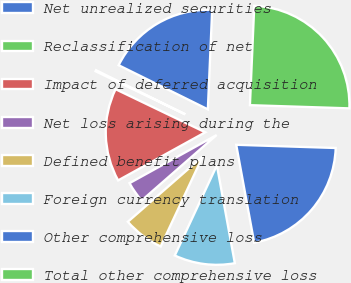Convert chart. <chart><loc_0><loc_0><loc_500><loc_500><pie_chart><fcel>Net unrealized securities<fcel>Reclassification of net<fcel>Impact of deferred acquisition<fcel>Net loss arising during the<fcel>Defined benefit plans<fcel>Foreign currency translation<fcel>Other comprehensive loss<fcel>Total other comprehensive loss<nl><fcel>18.38%<fcel>0.18%<fcel>15.16%<fcel>3.4%<fcel>6.62%<fcel>9.84%<fcel>21.6%<fcel>24.82%<nl></chart> 